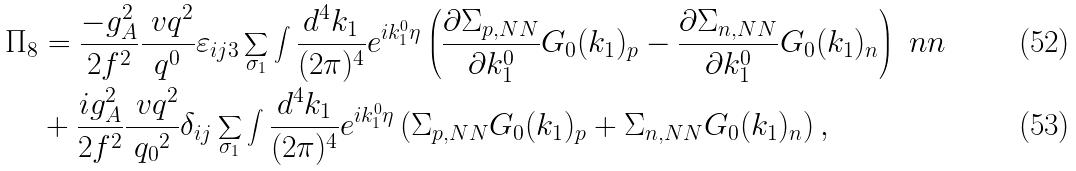Convert formula to latex. <formula><loc_0><loc_0><loc_500><loc_500>\Pi _ { 8 } & = \frac { - g _ { A } ^ { 2 } } { 2 f ^ { 2 } } \frac { \ v q ^ { 2 } } { q ^ { 0 } } \varepsilon _ { i j 3 } \sum _ { \sigma _ { 1 } } \int \frac { d ^ { 4 } k _ { 1 } } { ( 2 \pi ) ^ { 4 } } e ^ { i k _ { 1 } ^ { 0 } \eta } \left ( \frac { \partial \Sigma _ { p , N N } } { \partial k _ { 1 } ^ { 0 } } G _ { 0 } ( k _ { 1 } ) _ { p } - \frac { \partial \Sigma _ { n , N N } } { \partial k _ { 1 } ^ { 0 } } G _ { 0 } ( k _ { 1 } ) _ { n } \right ) \ n n \\ & + \frac { i g _ { A } ^ { 2 } } { 2 f ^ { 2 } } \frac { \ v q ^ { 2 } } { { q _ { 0 } } ^ { 2 } } \delta _ { i j } \sum _ { \sigma _ { 1 } } \int \frac { d ^ { 4 } k _ { 1 } } { ( 2 \pi ) ^ { 4 } } e ^ { i k _ { 1 } ^ { 0 } \eta } \left ( \Sigma _ { p , N N } G _ { 0 } ( k _ { 1 } ) _ { p } + \Sigma _ { n , N N } G _ { 0 } ( k _ { 1 } ) _ { n } \right ) ,</formula> 